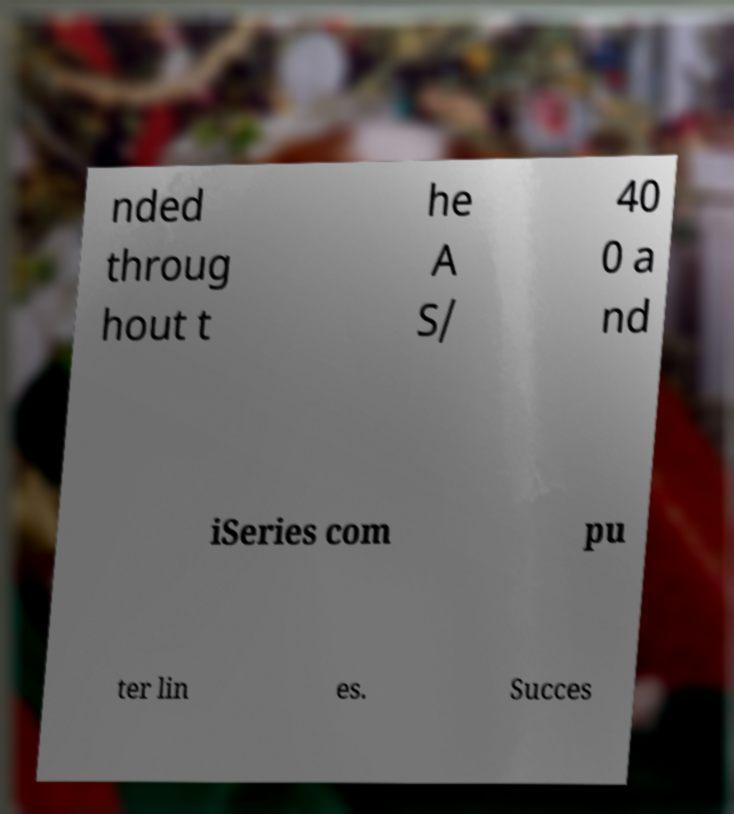Please identify and transcribe the text found in this image. nded throug hout t he A S/ 40 0 a nd iSeries com pu ter lin es. Succes 